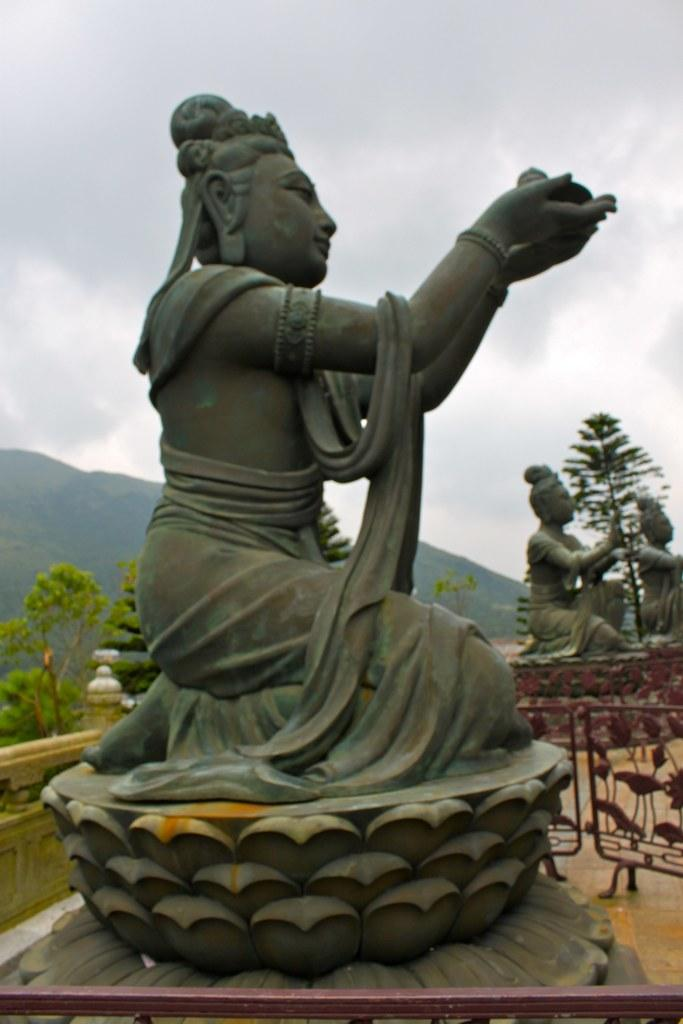What can be seen in the image that represents artistic or historical significance? There are statues in the image. What objects are present to control the flow of people or vehicles in the image? There are barriers in the image. What type of natural environment is visible in the background of the image? There are trees and mountains in the background of the image. What is the weather condition in the image? The sky is covered with clouds in the image. How many rabbits can be seen hopping around the statues in the image? There are no rabbits present in the image; it only features statues, barriers, trees, mountains, and a cloudy sky. What type of creature is depicted on the statues in the image? The statues in the image do not depict any creatures; they represent artistic or historical significance. 